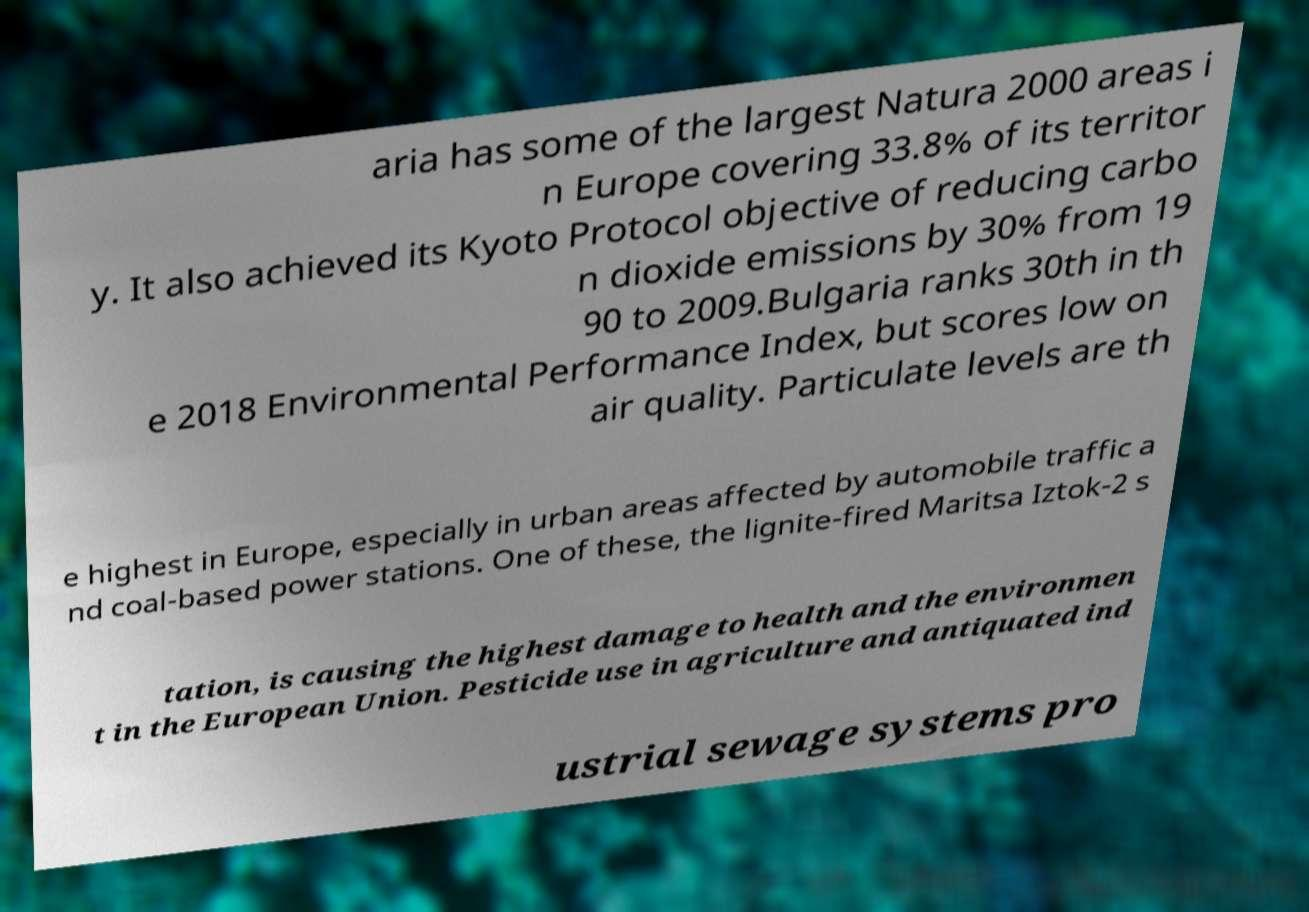Can you accurately transcribe the text from the provided image for me? aria has some of the largest Natura 2000 areas i n Europe covering 33.8% of its territor y. It also achieved its Kyoto Protocol objective of reducing carbo n dioxide emissions by 30% from 19 90 to 2009.Bulgaria ranks 30th in th e 2018 Environmental Performance Index, but scores low on air quality. Particulate levels are th e highest in Europe, especially in urban areas affected by automobile traffic a nd coal-based power stations. One of these, the lignite-fired Maritsa Iztok-2 s tation, is causing the highest damage to health and the environmen t in the European Union. Pesticide use in agriculture and antiquated ind ustrial sewage systems pro 